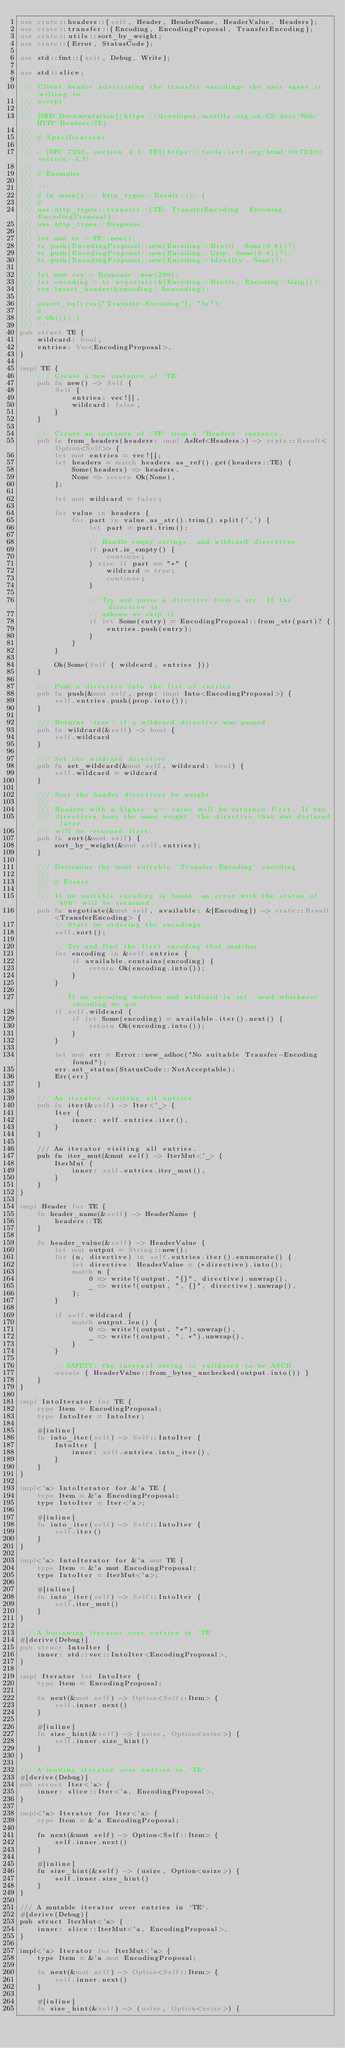<code> <loc_0><loc_0><loc_500><loc_500><_Rust_>use crate::headers::{self, Header, HeaderName, HeaderValue, Headers};
use crate::transfer::{Encoding, EncodingProposal, TransferEncoding};
use crate::utils::sort_by_weight;
use crate::{Error, StatusCode};

use std::fmt::{self, Debug, Write};

use std::slice;

/// Client header advertising the transfer encodings the user agent is willing to
/// accept.
///
/// [MDN Documentation](https://developer.mozilla.org/en-US/docs/Web/HTTP/Headers/TE)
///
/// # Specifications
///
/// - [RFC 7230, section 4.3: TE](https://tools.ietf.org/html/rfc7230#section-4.3)
///
/// # Examples
///
/// ```
/// # fn main() -> http_types::Result<()> {
/// #
/// use http_types::transfer::{TE, TransferEncoding, Encoding, EncodingProposal};
/// use http_types::Response;
///
/// let mut te = TE::new();
/// te.push(EncodingProposal::new(Encoding::Brotli, Some(0.8))?);
/// te.push(EncodingProposal::new(Encoding::Gzip, Some(0.4))?);
/// te.push(EncodingProposal::new(Encoding::Identity, None)?);
///
/// let mut res = Response::new(200);
/// let encoding = te.negotiate(&[Encoding::Brotli, Encoding::Gzip])?;
/// res.insert_header(&encoding, &encoding);
///
/// assert_eq!(res["Transfer-Encoding"], "br");
/// #
/// # Ok(()) }
/// ```
pub struct TE {
    wildcard: bool,
    entries: Vec<EncodingProposal>,
}

impl TE {
    /// Create a new instance of `TE`.
    pub fn new() -> Self {
        Self {
            entries: vec![],
            wildcard: false,
        }
    }

    /// Create an instance of `TE` from a `Headers` instance.
    pub fn from_headers(headers: impl AsRef<Headers>) -> crate::Result<Option<Self>> {
        let mut entries = vec![];
        let headers = match headers.as_ref().get(headers::TE) {
            Some(headers) => headers,
            None => return Ok(None),
        };

        let mut wildcard = false;

        for value in headers {
            for part in value.as_str().trim().split(',') {
                let part = part.trim();

                // Handle empty strings, and wildcard directives.
                if part.is_empty() {
                    continue;
                } else if part == "*" {
                    wildcard = true;
                    continue;
                }

                // Try and parse a directive from a str. If the directive is
                // unkown we skip it.
                if let Some(entry) = EncodingProposal::from_str(part)? {
                    entries.push(entry);
                }
            }
        }

        Ok(Some(Self { wildcard, entries }))
    }

    /// Push a directive into the list of entries.
    pub fn push(&mut self, prop: impl Into<EncodingProposal>) {
        self.entries.push(prop.into());
    }

    /// Returns `true` if a wildcard directive was passed.
    pub fn wildcard(&self) -> bool {
        self.wildcard
    }

    /// Set the wildcard directive.
    pub fn set_wildcard(&mut self, wildcard: bool) {
        self.wildcard = wildcard
    }

    /// Sort the header directives by weight.
    ///
    /// Headers with a higher `q=` value will be returned first. If two
    /// directives have the same weight, the directive that was declared later
    /// will be returned first.
    pub fn sort(&mut self) {
        sort_by_weight(&mut self.entries);
    }

    /// Determine the most suitable `Transfer-Encoding` encoding.
    ///
    /// # Errors
    ///
    /// If no suitable encoding is found, an error with the status of `406` will be returned.
    pub fn negotiate(&mut self, available: &[Encoding]) -> crate::Result<TransferEncoding> {
        // Start by ordering the encodings.
        self.sort();

        // Try and find the first encoding that matches.
        for encoding in &self.entries {
            if available.contains(encoding) {
                return Ok(encoding.into());
            }
        }

        // If no encoding matches and wildcard is set, send whichever encoding we got.
        if self.wildcard {
            if let Some(encoding) = available.iter().next() {
                return Ok(encoding.into());
            }
        }

        let mut err = Error::new_adhoc("No suitable Transfer-Encoding found");
        err.set_status(StatusCode::NotAcceptable);
        Err(err)
    }

    /// An iterator visiting all entries.
    pub fn iter(&self) -> Iter<'_> {
        Iter {
            inner: self.entries.iter(),
        }
    }

    /// An iterator visiting all entries.
    pub fn iter_mut(&mut self) -> IterMut<'_> {
        IterMut {
            inner: self.entries.iter_mut(),
        }
    }
}

impl Header for TE {
    fn header_name(&self) -> HeaderName {
        headers::TE
    }

    fn header_value(&self) -> HeaderValue {
        let mut output = String::new();
        for (n, directive) in self.entries.iter().enumerate() {
            let directive: HeaderValue = (*directive).into();
            match n {
                0 => write!(output, "{}", directive).unwrap(),
                _ => write!(output, ", {}", directive).unwrap(),
            };
        }

        if self.wildcard {
            match output.len() {
                0 => write!(output, "*").unwrap(),
                _ => write!(output, ", *").unwrap(),
            }
        }

        // SAFETY: the internal string is validated to be ASCII.
        unsafe { HeaderValue::from_bytes_unchecked(output.into()) }
    }
}

impl IntoIterator for TE {
    type Item = EncodingProposal;
    type IntoIter = IntoIter;

    #[inline]
    fn into_iter(self) -> Self::IntoIter {
        IntoIter {
            inner: self.entries.into_iter(),
        }
    }
}

impl<'a> IntoIterator for &'a TE {
    type Item = &'a EncodingProposal;
    type IntoIter = Iter<'a>;

    #[inline]
    fn into_iter(self) -> Self::IntoIter {
        self.iter()
    }
}

impl<'a> IntoIterator for &'a mut TE {
    type Item = &'a mut EncodingProposal;
    type IntoIter = IterMut<'a>;

    #[inline]
    fn into_iter(self) -> Self::IntoIter {
        self.iter_mut()
    }
}

/// A borrowing iterator over entries in `TE`.
#[derive(Debug)]
pub struct IntoIter {
    inner: std::vec::IntoIter<EncodingProposal>,
}

impl Iterator for IntoIter {
    type Item = EncodingProposal;

    fn next(&mut self) -> Option<Self::Item> {
        self.inner.next()
    }

    #[inline]
    fn size_hint(&self) -> (usize, Option<usize>) {
        self.inner.size_hint()
    }
}

/// A lending iterator over entries in `TE`.
#[derive(Debug)]
pub struct Iter<'a> {
    inner: slice::Iter<'a, EncodingProposal>,
}

impl<'a> Iterator for Iter<'a> {
    type Item = &'a EncodingProposal;

    fn next(&mut self) -> Option<Self::Item> {
        self.inner.next()
    }

    #[inline]
    fn size_hint(&self) -> (usize, Option<usize>) {
        self.inner.size_hint()
    }
}

/// A mutable iterator over entries in `TE`.
#[derive(Debug)]
pub struct IterMut<'a> {
    inner: slice::IterMut<'a, EncodingProposal>,
}

impl<'a> Iterator for IterMut<'a> {
    type Item = &'a mut EncodingProposal;

    fn next(&mut self) -> Option<Self::Item> {
        self.inner.next()
    }

    #[inline]
    fn size_hint(&self) -> (usize, Option<usize>) {</code> 